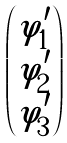Convert formula to latex. <formula><loc_0><loc_0><loc_500><loc_500>\begin{pmatrix} \varphi ^ { \prime } _ { 1 } \\ \varphi ^ { \prime } _ { 2 } \\ \varphi ^ { \prime } _ { 3 } \end{pmatrix}</formula> 